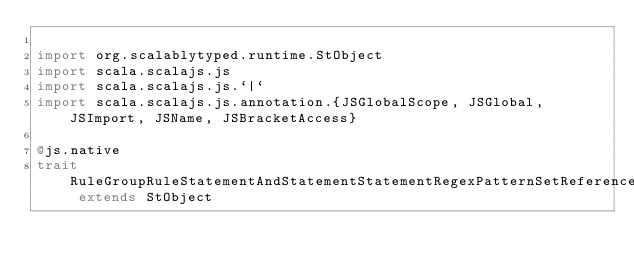<code> <loc_0><loc_0><loc_500><loc_500><_Scala_>
import org.scalablytyped.runtime.StObject
import scala.scalajs.js
import scala.scalajs.js.`|`
import scala.scalajs.js.annotation.{JSGlobalScope, JSGlobal, JSImport, JSName, JSBracketAccess}

@js.native
trait RuleGroupRuleStatementAndStatementStatementRegexPatternSetReferenceStatementFieldToMatchMethod extends StObject
</code> 